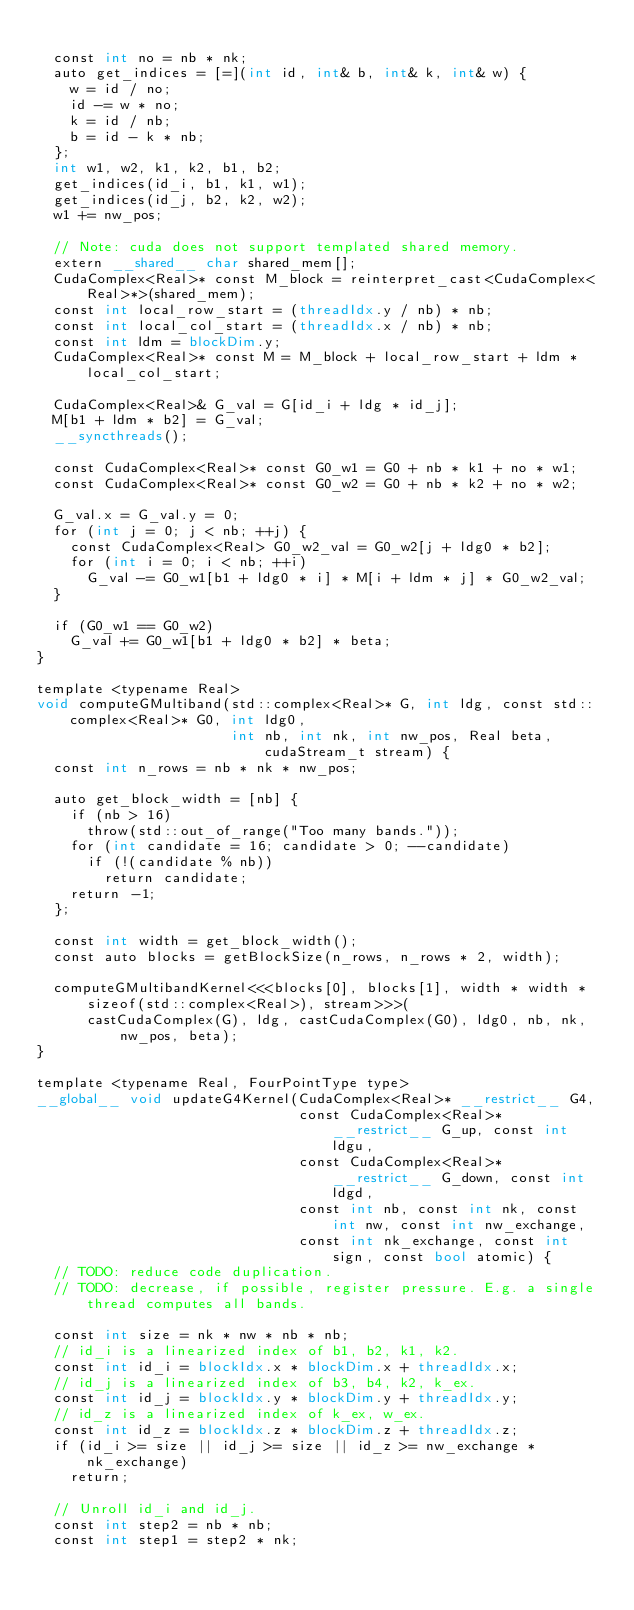<code> <loc_0><loc_0><loc_500><loc_500><_Cuda_>
  const int no = nb * nk;
  auto get_indices = [=](int id, int& b, int& k, int& w) {
    w = id / no;
    id -= w * no;
    k = id / nb;
    b = id - k * nb;
  };
  int w1, w2, k1, k2, b1, b2;
  get_indices(id_i, b1, k1, w1);
  get_indices(id_j, b2, k2, w2);
  w1 += nw_pos;

  // Note: cuda does not support templated shared memory.
  extern __shared__ char shared_mem[];
  CudaComplex<Real>* const M_block = reinterpret_cast<CudaComplex<Real>*>(shared_mem);
  const int local_row_start = (threadIdx.y / nb) * nb;
  const int local_col_start = (threadIdx.x / nb) * nb;
  const int ldm = blockDim.y;
  CudaComplex<Real>* const M = M_block + local_row_start + ldm * local_col_start;

  CudaComplex<Real>& G_val = G[id_i + ldg * id_j];
  M[b1 + ldm * b2] = G_val;
  __syncthreads();

  const CudaComplex<Real>* const G0_w1 = G0 + nb * k1 + no * w1;
  const CudaComplex<Real>* const G0_w2 = G0 + nb * k2 + no * w2;

  G_val.x = G_val.y = 0;
  for (int j = 0; j < nb; ++j) {
    const CudaComplex<Real> G0_w2_val = G0_w2[j + ldg0 * b2];
    for (int i = 0; i < nb; ++i)
      G_val -= G0_w1[b1 + ldg0 * i] * M[i + ldm * j] * G0_w2_val;
  }

  if (G0_w1 == G0_w2)
    G_val += G0_w1[b1 + ldg0 * b2] * beta;
}

template <typename Real>
void computeGMultiband(std::complex<Real>* G, int ldg, const std::complex<Real>* G0, int ldg0,
                       int nb, int nk, int nw_pos, Real beta, cudaStream_t stream) {
  const int n_rows = nb * nk * nw_pos;

  auto get_block_width = [nb] {
    if (nb > 16)
      throw(std::out_of_range("Too many bands."));
    for (int candidate = 16; candidate > 0; --candidate)
      if (!(candidate % nb))
        return candidate;
    return -1;
  };

  const int width = get_block_width();
  const auto blocks = getBlockSize(n_rows, n_rows * 2, width);

  computeGMultibandKernel<<<blocks[0], blocks[1], width * width * sizeof(std::complex<Real>), stream>>>(
      castCudaComplex(G), ldg, castCudaComplex(G0), ldg0, nb, nk, nw_pos, beta);
}

template <typename Real, FourPointType type>
__global__ void updateG4Kernel(CudaComplex<Real>* __restrict__ G4,
                               const CudaComplex<Real>* __restrict__ G_up, const int ldgu,
                               const CudaComplex<Real>* __restrict__ G_down, const int ldgd,
                               const int nb, const int nk, const int nw, const int nw_exchange,
                               const int nk_exchange, const int sign, const bool atomic) {
  // TODO: reduce code duplication.
  // TODO: decrease, if possible, register pressure. E.g. a single thread computes all bands.

  const int size = nk * nw * nb * nb;
  // id_i is a linearized index of b1, b2, k1, k2.
  const int id_i = blockIdx.x * blockDim.x + threadIdx.x;
  // id_j is a linearized index of b3, b4, k2, k_ex.
  const int id_j = blockIdx.y * blockDim.y + threadIdx.y;
  // id_z is a linearized index of k_ex, w_ex.
  const int id_z = blockIdx.z * blockDim.z + threadIdx.z;
  if (id_i >= size || id_j >= size || id_z >= nw_exchange * nk_exchange)
    return;

  // Unroll id_i and id_j.
  const int step2 = nb * nb;
  const int step1 = step2 * nk;</code> 